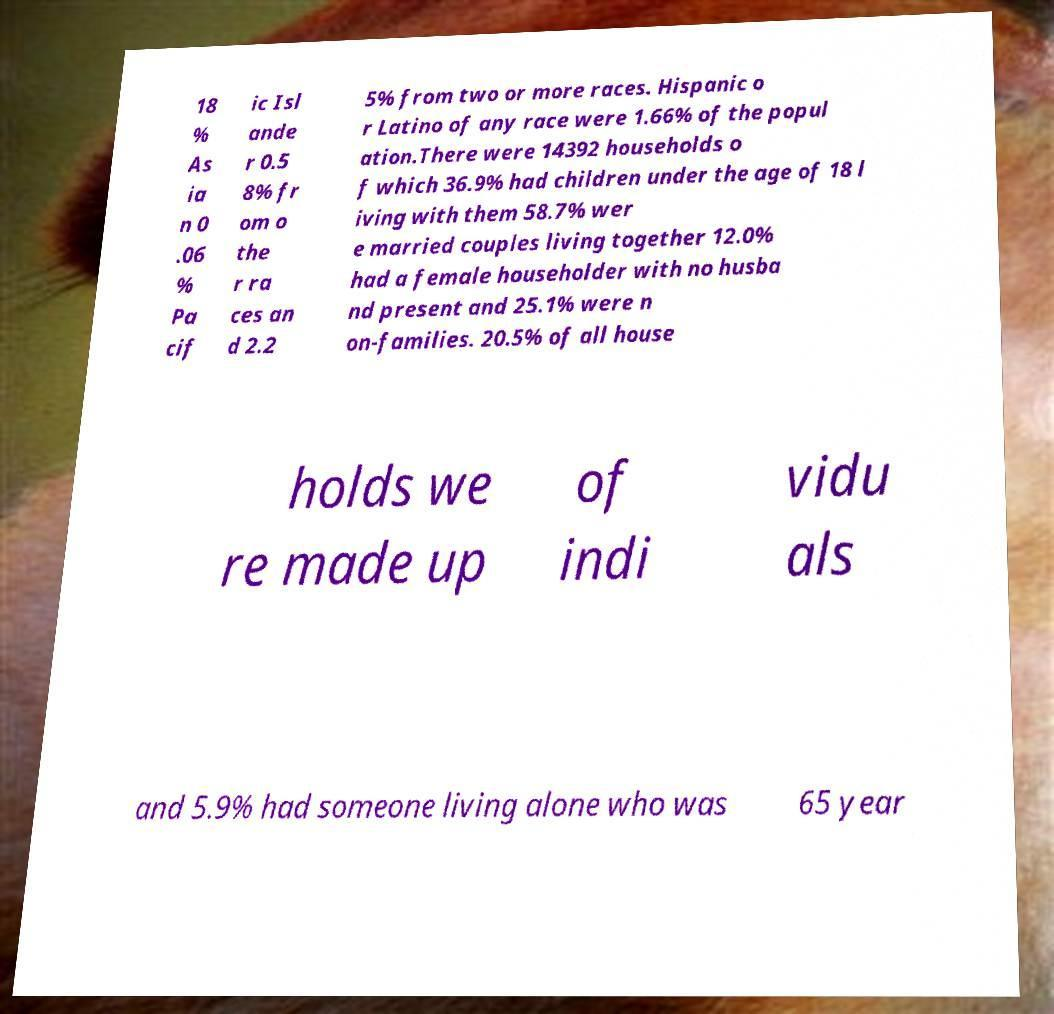What messages or text are displayed in this image? I need them in a readable, typed format. 18 % As ia n 0 .06 % Pa cif ic Isl ande r 0.5 8% fr om o the r ra ces an d 2.2 5% from two or more races. Hispanic o r Latino of any race were 1.66% of the popul ation.There were 14392 households o f which 36.9% had children under the age of 18 l iving with them 58.7% wer e married couples living together 12.0% had a female householder with no husba nd present and 25.1% were n on-families. 20.5% of all house holds we re made up of indi vidu als and 5.9% had someone living alone who was 65 year 